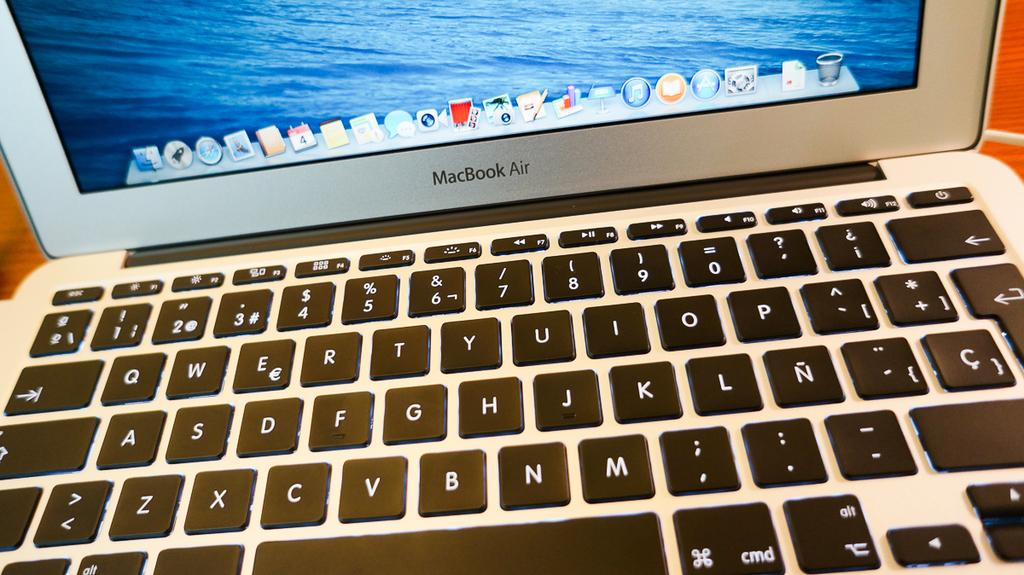<image>
Relay a brief, clear account of the picture shown. A MacBook Air has an ocean-themed background image. 